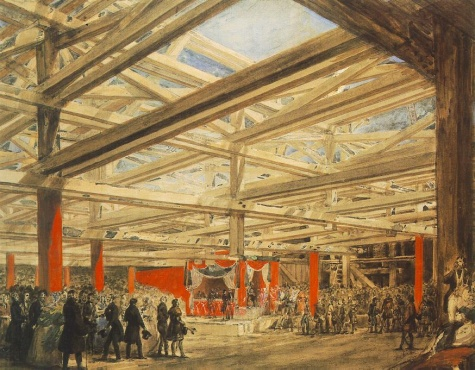What do you see happening in this image? This artwork captures a lively scene within a grand hall. The hall is characterized by its high ceiling, supported by robust wooden beams. The space is teeming with people, creating a sense of bustling activity. Some individuals are standing, engaged in conversation or observation, while others are seated, perhaps taking a moment to rest or simply absorb the atmosphere.

The stage, adorned with vibrant red curtains, serves as the focal point of the painting. A throne is prominently placed on the stage, suggesting the presence or anticipation of a person of importance. 

The painting is executed in a realistic style, with meticulous attention to detail that enhances the overall authenticity of the scene. The use of perspective and shading techniques contributes to the depth and three-dimensionality of the image. 

Based on the style and subject matter, the painting appears to be from the 19th century. It could potentially belong to the genre of historical or genre painting, both of which were popular during this period. However, without additional information, this is purely speculative. 

Overall, the painting provides a fascinating glimpse into a particular moment in time, skillfully brought to life through the artist's careful observation and technical prowess. 